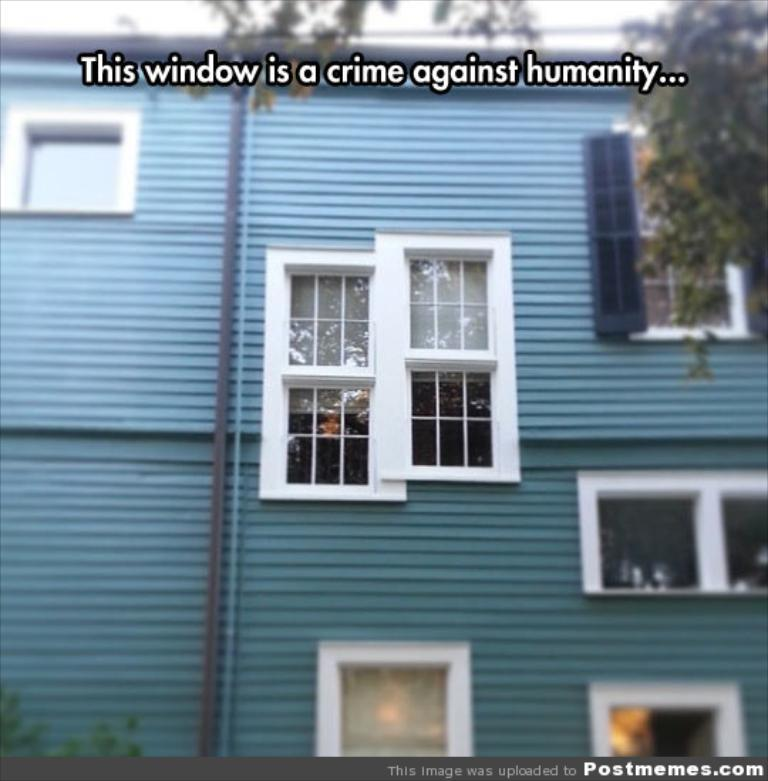What type of structure is present in the image? There is a building in the image. What feature can be seen on the building? The building has windows. What is written at the top of the image? There is text at the top of the image. What is written along the border at the bottom of the image? There is text on the border at the bottom of the image. Can you see a group of kittens playing with a balloon in the image? There is no group of kittens or balloon present in the image. 